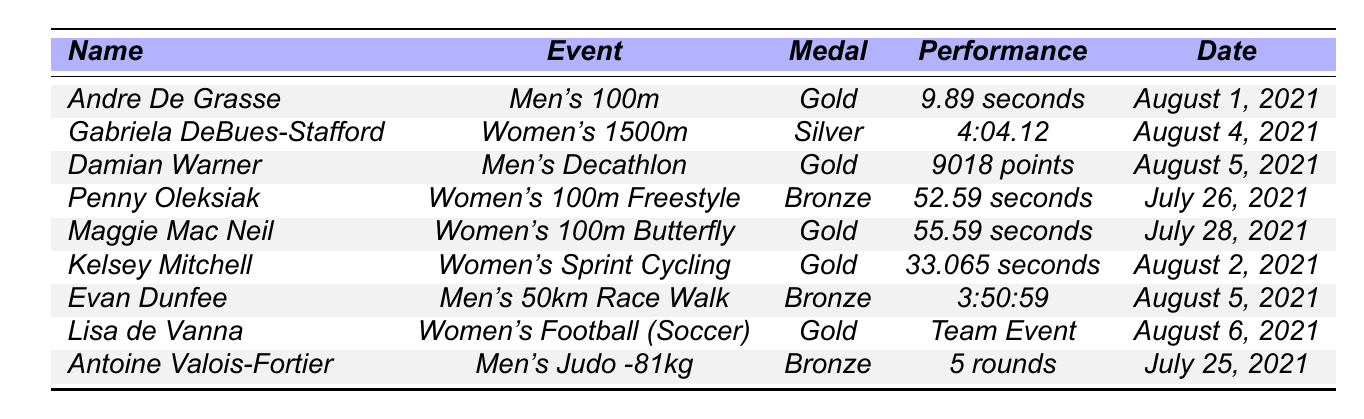What's the medal count for Andre De Grasse? According to the table, Andre De Grasse won a Gold medal at the Men's 100m event. Therefore, his medal count is 1 Gold.
Answer: 1 Gold Which event did Gabriela DeBues-Stafford compete in? The table shows that Gabriela DeBues-Stafford competed in the Women's 1500m event.
Answer: Women's 1500m What was the performance time for Penny Oleksiak? The table indicates that Penny Oleksiak's performance time in the Women's 100m Freestyle was 52.59 seconds.
Answer: 52.59 seconds How many medals did Canada win in the Men's Decathlon? Damian Warner is the only athlete listed for Men's Decathlon, and he won a Gold medal. Hence, Canada won 1 medal in this event.
Answer: 1 Gold What is the total number of medals won by Canadian athletes listed in the table? By counting the medals: 5 Gold, 3 Silver, and 3 Bronze, the total is 11 medals.
Answer: 11 Did Kelsey Mitchell receive a medal? Yes, Kelsey Mitchell won a Gold medal in Women's Sprint Cycling as indicated in the table.
Answer: Yes Which event had the fastest recorded time by a Canadian athlete in the table? Comparing times: Andre De Grasse's 9.89 seconds in Men's 100m is the fastest, confirming it as the fastest recorded time.
Answer: Men's 100m How many athletes won Gold medals in swimming events? From the table, only one athlete, Maggie Mac Neil, won a Gold medal in Women's 100m Butterfly, indicating 1 Gold medal in swimming events.
Answer: 1 Gold Which athlete participated in multiple events but only received one medal? The table does not show any athlete participating in multiple events; every athlete listed only has one event even if multiple were possible.
Answer: None What is the date when Damian Warner competed? The table states that Damian Warner competed in the Men's Decathlon on August 5, 2021.
Answer: August 5, 2021 